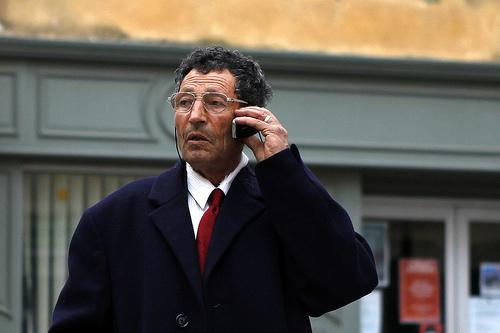Question: what is the man doing?
Choices:
A. Talking on a tablet.
B. Talking on his Iphone.
C. Talking on his Blackberry.
D. Talking on a cell phone.
Answer with the letter. Answer: D Question: how is he dressed?
Choices:
A. Leather jacket.
B. In a blue coat.
C. Black suit.
D. Windbreaker.
Answer with the letter. Answer: B Question: what is he holding?
Choices:
A. Walkie talkie.
B. Pen.
C. Tape measure.
D. A cell phone.
Answer with the letter. Answer: D Question: why is he outside?
Choices:
A. He's walking and talking.
B. Getting mail.
C. Taking out trash.
D. Locking car.
Answer with the letter. Answer: A 